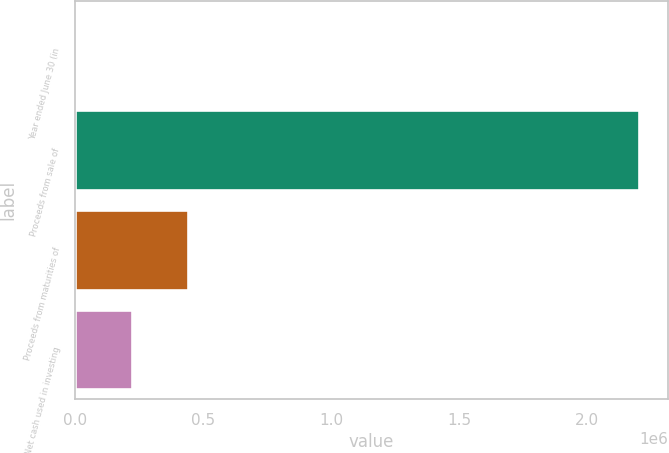<chart> <loc_0><loc_0><loc_500><loc_500><bar_chart><fcel>Year ended June 30 (in<fcel>Proceeds from sale of<fcel>Proceeds from maturities of<fcel>Net cash used in investing<nl><fcel>2005<fcel>2.20535e+06<fcel>442675<fcel>222340<nl></chart> 